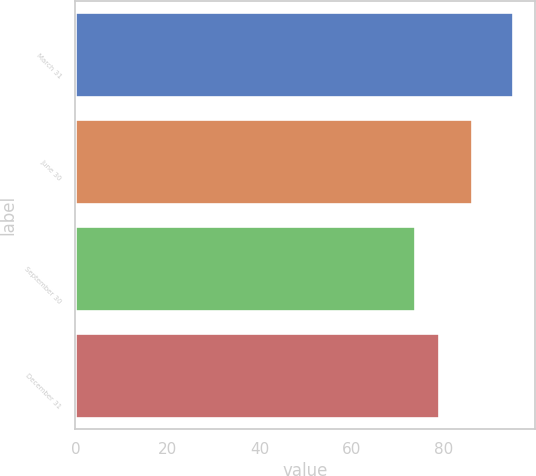<chart> <loc_0><loc_0><loc_500><loc_500><bar_chart><fcel>March 31<fcel>June 30<fcel>September 30<fcel>December 31<nl><fcel>94.98<fcel>86.11<fcel>73.73<fcel>78.89<nl></chart> 